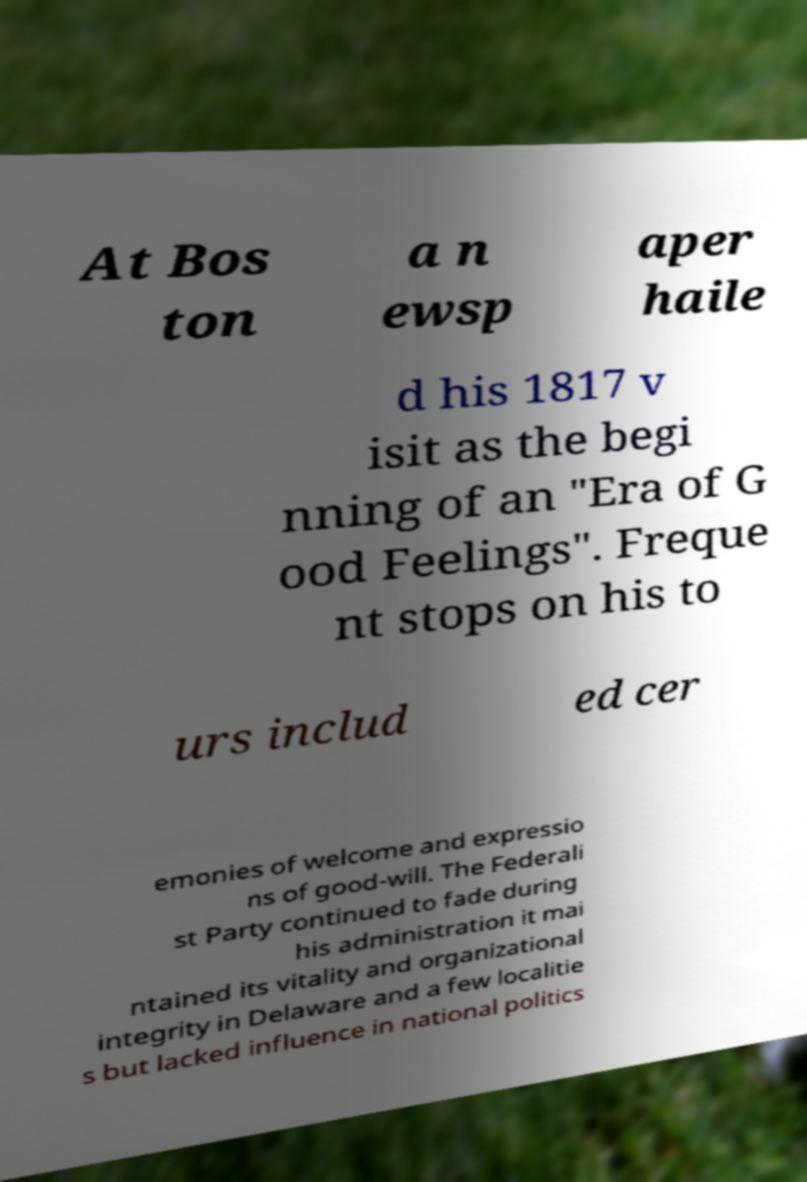For documentation purposes, I need the text within this image transcribed. Could you provide that? At Bos ton a n ewsp aper haile d his 1817 v isit as the begi nning of an "Era of G ood Feelings". Freque nt stops on his to urs includ ed cer emonies of welcome and expressio ns of good-will. The Federali st Party continued to fade during his administration it mai ntained its vitality and organizational integrity in Delaware and a few localitie s but lacked influence in national politics 